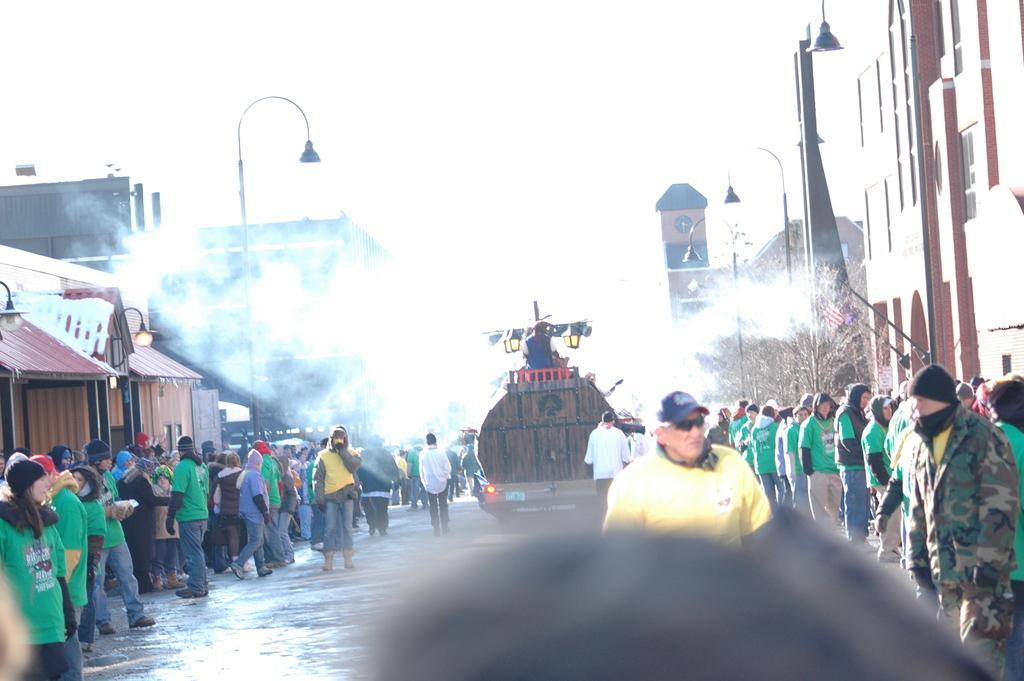Please provide a concise description of this image. In the center of the image we can see one vehicle on the road. On the vehicle, we can see one person is sitting. And we can see a group of people are standing and they are in different costumes. Among them, we can see a few people are holding some objects and a few people are wearing caps. In the background we can see the sky, buildings, trees, one clock tower, poles, smoke, flags and a few other objects. 